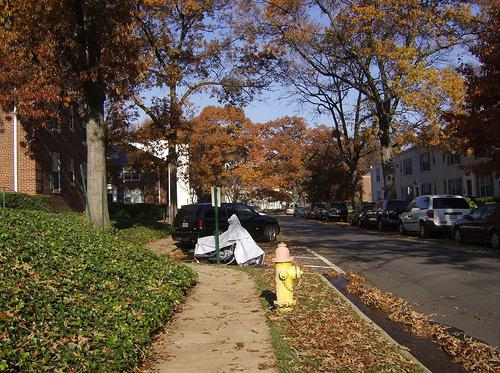What is the most likely reason that the bike is covered where it is? Please explain your reasoning. protection. The bike is covered for protection. 